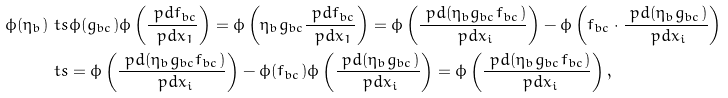<formula> <loc_0><loc_0><loc_500><loc_500>\phi ( \eta _ { b } ) & \ t s \phi ( g _ { b c } ) \phi \left ( \frac { \ p d f _ { b c } } { \ p d x _ { 1 } } \right ) = \phi \left ( \eta _ { b } g _ { b c } \frac { \ p d f _ { b c } } { \ p d x _ { 1 } } \right ) = \phi \left ( \frac { \ p d ( \eta _ { b } g _ { b c } f _ { b c } ) } { \ p d x _ { i } } \right ) - \phi \left ( f _ { b c } \cdot \frac { \ p d ( \eta _ { b } g _ { b c } ) } { \ p d x _ { i } } \right ) \\ & \ t s = \phi \left ( \frac { \ p d ( \eta _ { b } g _ { b c } f _ { b c } ) } { \ p d x _ { i } } \right ) - \phi ( f _ { b c } ) \phi \left ( \frac { \ p d ( \eta _ { b } g _ { b c } ) } { \ p d x _ { i } } \right ) = \phi \left ( \frac { \ p d ( \eta _ { b } g _ { b c } f _ { b c } ) } { \ p d x _ { i } } \right ) ,</formula> 